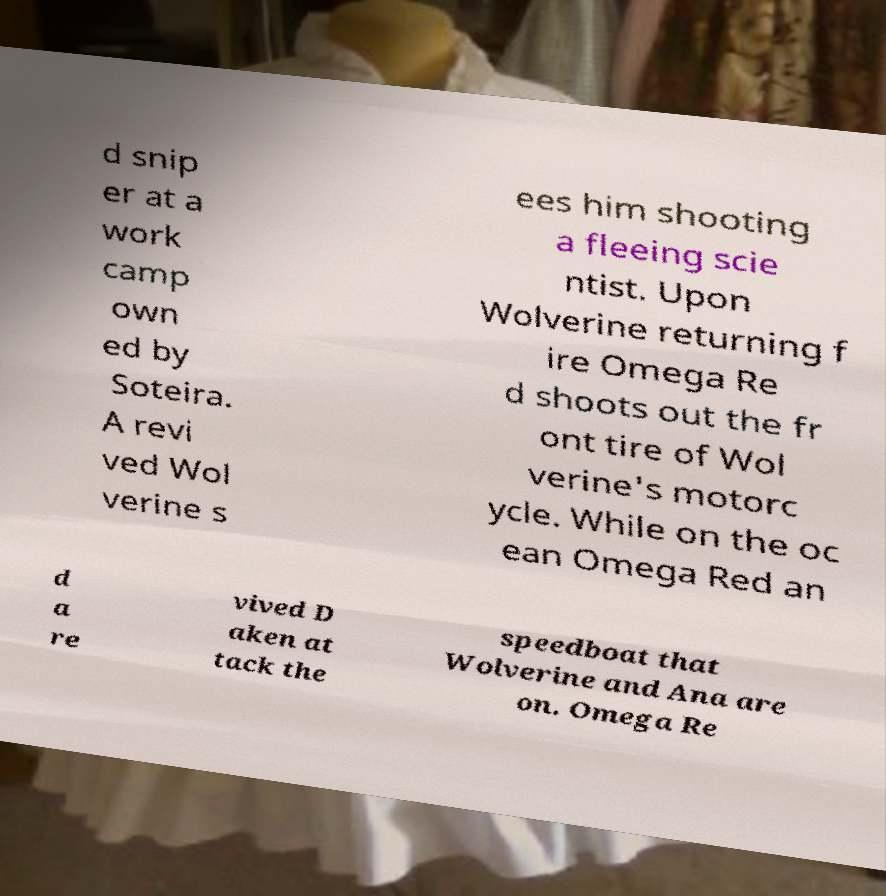Please identify and transcribe the text found in this image. d snip er at a work camp own ed by Soteira. A revi ved Wol verine s ees him shooting a fleeing scie ntist. Upon Wolverine returning f ire Omega Re d shoots out the fr ont tire of Wol verine's motorc ycle. While on the oc ean Omega Red an d a re vived D aken at tack the speedboat that Wolverine and Ana are on. Omega Re 